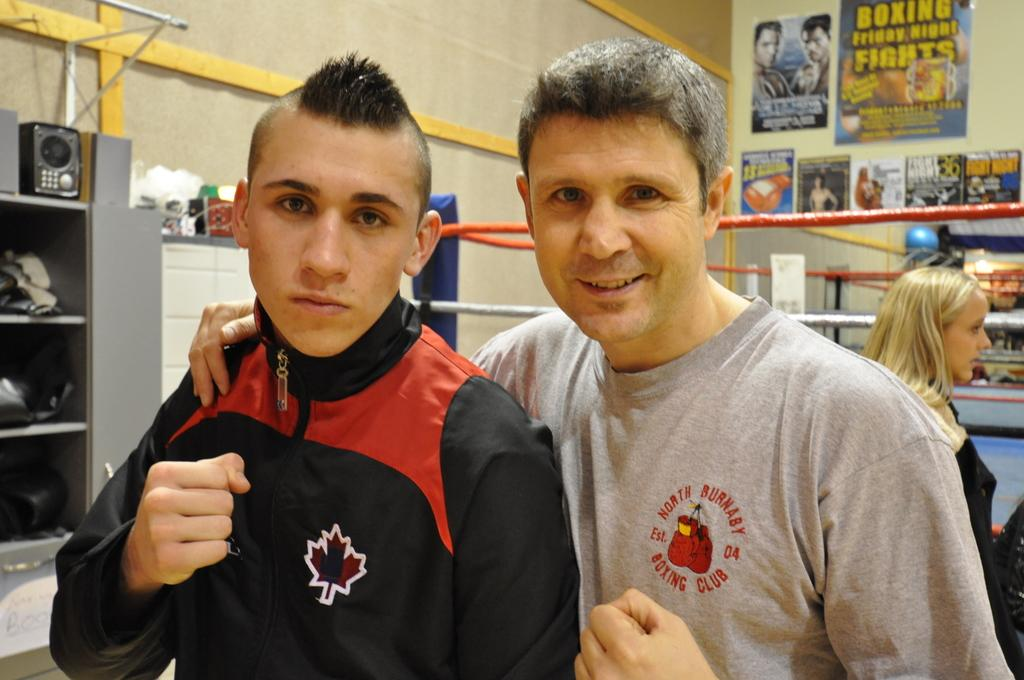<image>
Summarize the visual content of the image. A guy wearing a North Burnaby Boxing Club shirt. 